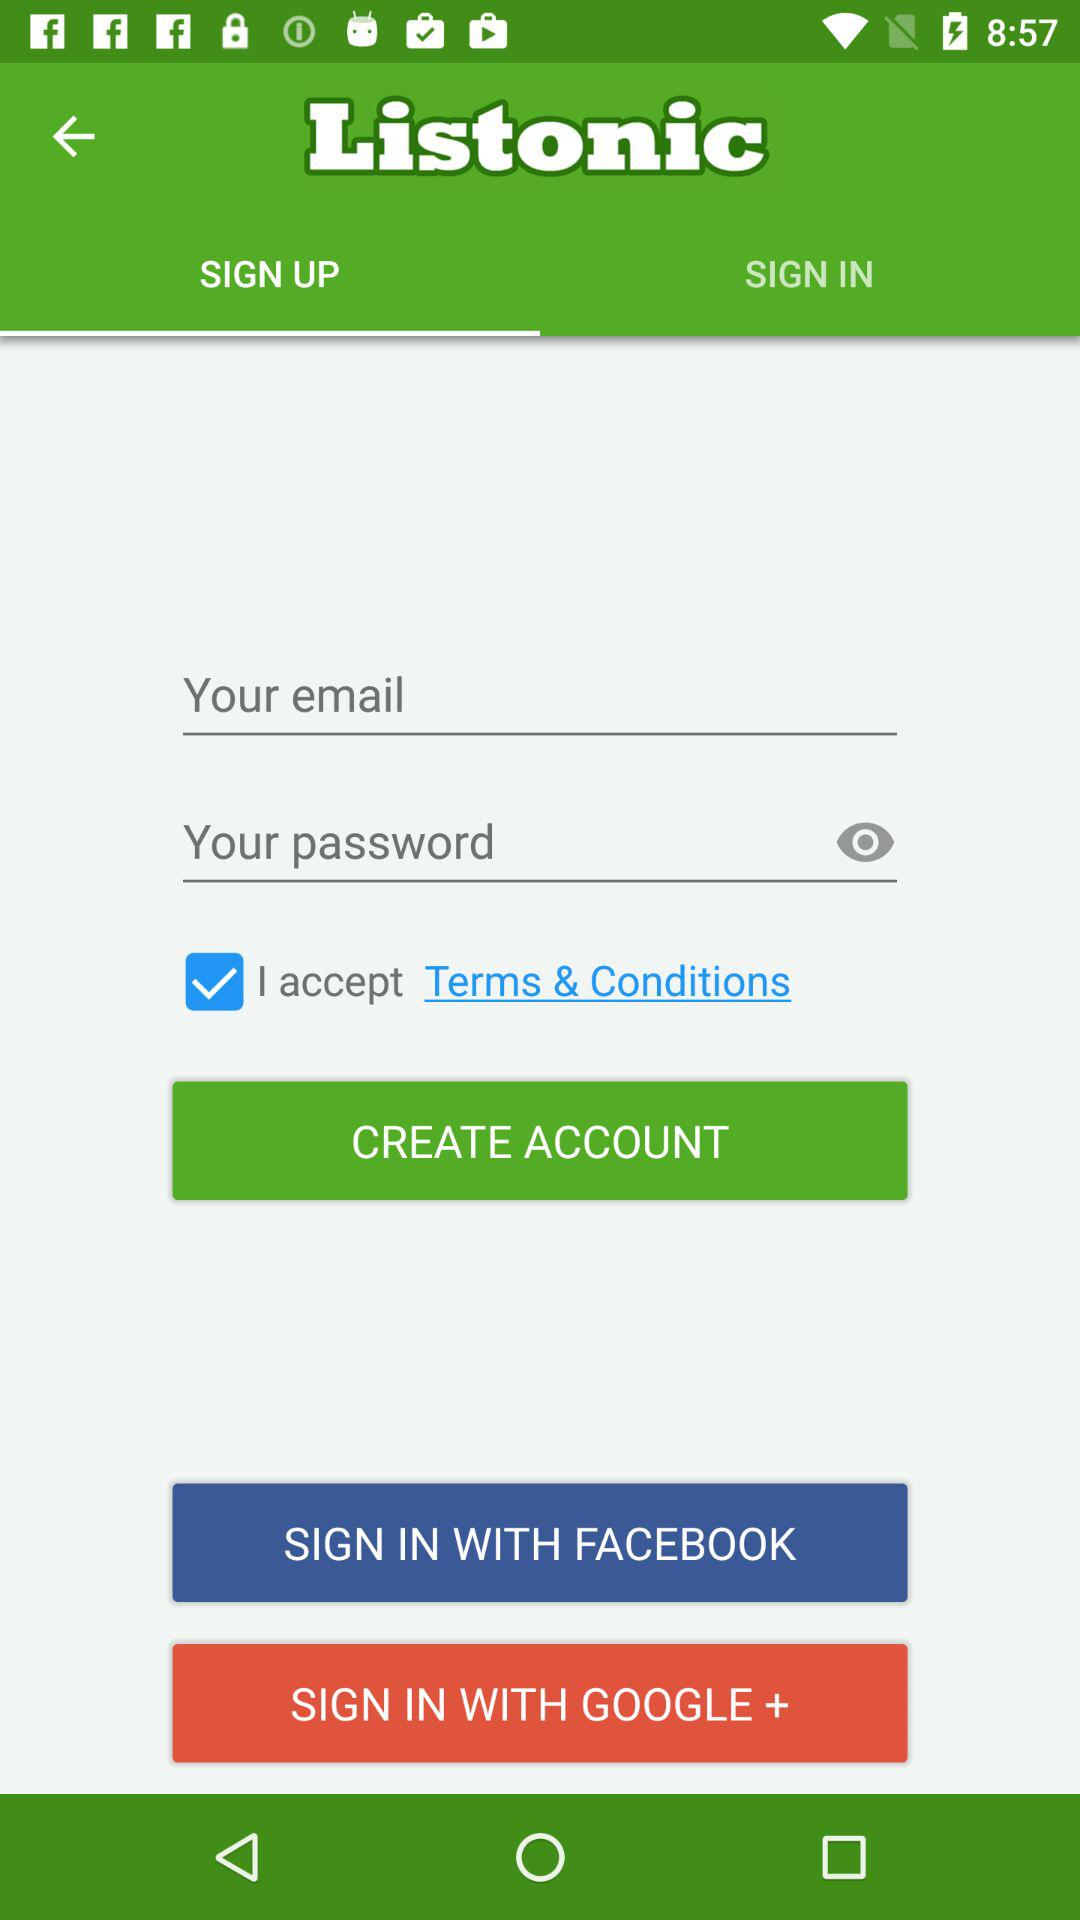How many more text inputs are there than checkboxes?
Answer the question using a single word or phrase. 1 